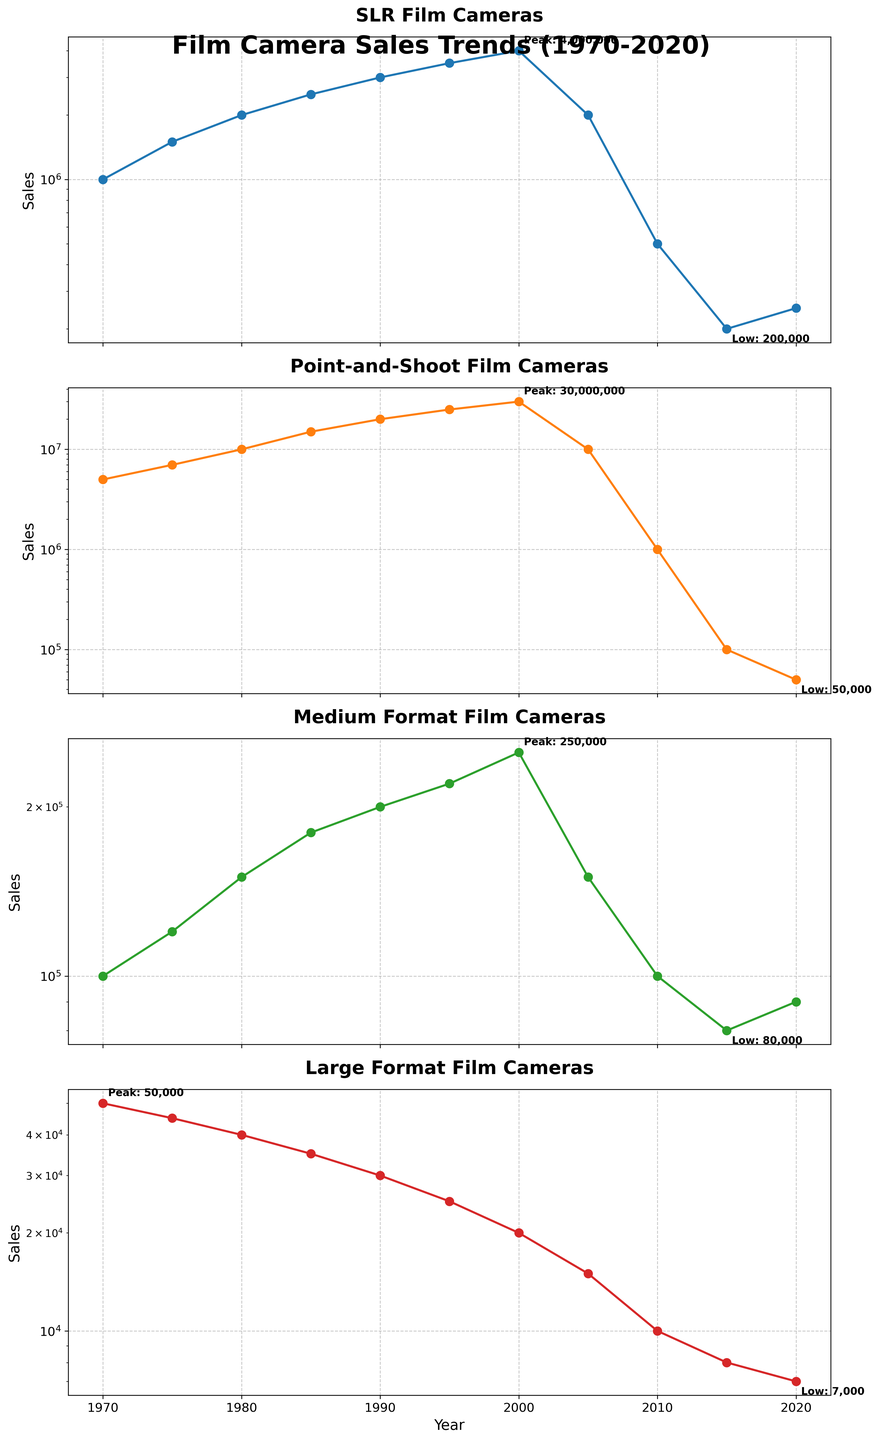What year saw the highest sales for SLR Film Cameras, and what were the sales? In the SLR Film Cameras subplot, the highest data point is annotated with "Peak". The year next to this annotation is 2000, and the sales figure is 4,000,000.
Answer: 2000, 4,000,000 Which camera type experienced the smallest decline in sales over the entire period? By observing the trends from 1970 to 2020 across all four subplots, Large Format Film Cameras show the smallest decline, from 50,000 to 7,000.
Answer: Large Format Film Cameras What were the sales of Point-and-Shoot Film Cameras in 1990, and how does it compare to the sales in 2010? The sales in 1990 are 20,000,000, and in 2010 the sales are 1,000,000. The difference is 20,000,000 - 1,000,000 = 19,000,000.
Answer: 19,000,000 decrease Which year marked the lowest sales of Medium Format Film Cameras, and what were the sales? The lowest point is marked with "Low" in the Medium Format Film Cameras subplot. The year is 2020, and the sales figure is 90,000.
Answer: 2020, 90,000 Compare the peak sales years for SLR Film Cameras and Point-and-Shoot Film Cameras and state which occurred first. The Peak sales year for SLR Film Cameras is 2000, while it is 1995 for Point-and-Shoot Film Cameras. 1995 occurred before 2000.
Answer: 1995 occurred first How do the sales trends for Large Format Film Cameras differ from the trends for Point-and-Shoot Film Cameras? The Large Format Film Cameras show a gradual decrease over time, whereas Point-and-Shoot Film Cameras show a sharp increase followed by a sharp decline.
Answer: Gradual decrease vs. sharp increase and decline Looking at the SLR Film Cameras sales in 2000 and 2010, calculate the percentage decrease. The sales in 2000 are 4,000,000 and in 2010 they are 500,000. The decrease is 4,000,000 - 500,000 = 3,500,000. The percentage decrease is (3,500,000 / 4,000,000) * 100 = 87.5%.
Answer: 87.5% Which camera type had the highest sales in 1970, and what were the sales? The Point-and-Shoot Film Cameras had the highest sales in 1970, 5,000,000, as shown in the respective subplot.
Answer: Point-and-Shoot Film Cameras, 5,000,000 What general trend can be observed for SLR Film Cameras and Medium Format Film Cameras sales over the fifty years? Both SLR Film Cameras and Medium Format Film Cameras show an increasing trend until 2000, followed by a decline.
Answer: Increase until 2000 then decline In which year were the Large Format Film Cameras sales closest to 15,000? By looking at the trend in the Large Format Film Cameras subplot, it occurs in 2005 with sales of exactly 15,000.
Answer: 2005 